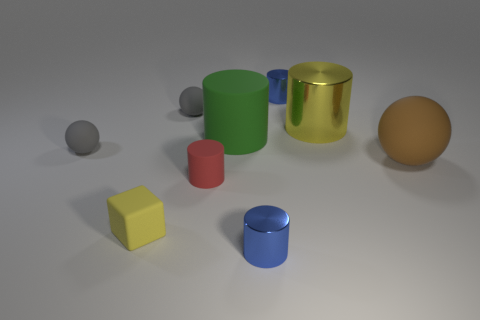Subtract all tiny rubber cylinders. How many cylinders are left? 4 Subtract all cyan cylinders. Subtract all red blocks. How many cylinders are left? 5 Add 1 large green objects. How many objects exist? 10 Subtract all cylinders. How many objects are left? 4 Add 3 tiny gray rubber spheres. How many tiny gray rubber spheres are left? 5 Add 8 gray objects. How many gray objects exist? 10 Subtract 0 gray cylinders. How many objects are left? 9 Subtract all small brown matte spheres. Subtract all red cylinders. How many objects are left? 8 